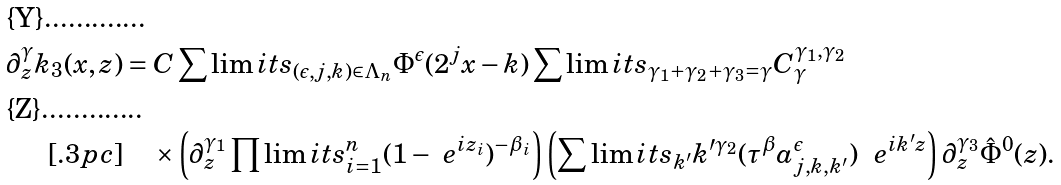Convert formula to latex. <formula><loc_0><loc_0><loc_500><loc_500>\partial ^ { \gamma } _ { z } k _ { 3 } ( x , z ) & = C \sum \lim i t s _ { ( \epsilon , j , k ) \in \Lambda _ { n } } \Phi ^ { \epsilon } ( 2 ^ { j } x - k ) \sum \lim i t s _ { \gamma _ { 1 } + \gamma _ { 2 } + \gamma _ { 3 } = \gamma } C ^ { \gamma _ { 1 } , \gamma _ { 2 } } _ { \gamma } \\ [ . 3 p c ] & \quad \times \left ( \partial ^ { \gamma _ { 1 } } _ { z } \prod \lim i t s ^ { n } _ { i = 1 } ( 1 - \ e ^ { i z _ { i } } ) ^ { - \beta _ { i } } \right ) \left ( \sum \lim i t s _ { k ^ { \prime } } k ^ { \prime \gamma _ { 2 } } ( \tau ^ { \beta } a ^ { \epsilon } _ { j , k , k ^ { \prime } } ) \ \ e ^ { i k ^ { \prime } z } \right ) \partial ^ { \gamma _ { 3 } } _ { z } \hat { \Phi } ^ { 0 } ( z ) .</formula> 